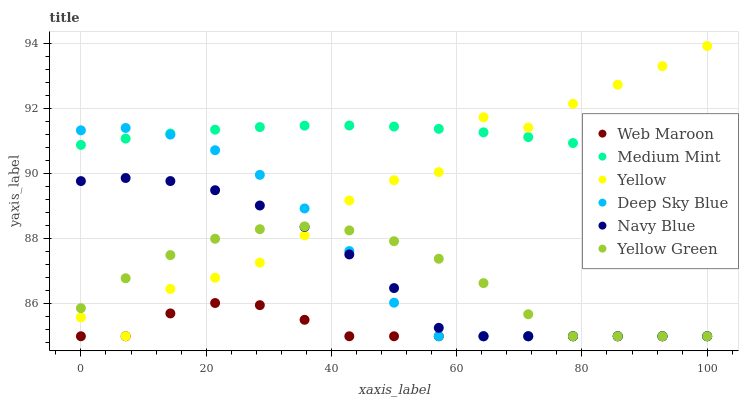Does Web Maroon have the minimum area under the curve?
Answer yes or no. Yes. Does Medium Mint have the maximum area under the curve?
Answer yes or no. Yes. Does Yellow Green have the minimum area under the curve?
Answer yes or no. No. Does Yellow Green have the maximum area under the curve?
Answer yes or no. No. Is Medium Mint the smoothest?
Answer yes or no. Yes. Is Yellow the roughest?
Answer yes or no. Yes. Is Yellow Green the smoothest?
Answer yes or no. No. Is Yellow Green the roughest?
Answer yes or no. No. Does Yellow Green have the lowest value?
Answer yes or no. Yes. Does Yellow have the lowest value?
Answer yes or no. No. Does Yellow have the highest value?
Answer yes or no. Yes. Does Yellow Green have the highest value?
Answer yes or no. No. Is Yellow Green less than Medium Mint?
Answer yes or no. Yes. Is Medium Mint greater than Yellow Green?
Answer yes or no. Yes. Does Navy Blue intersect Yellow Green?
Answer yes or no. Yes. Is Navy Blue less than Yellow Green?
Answer yes or no. No. Is Navy Blue greater than Yellow Green?
Answer yes or no. No. Does Yellow Green intersect Medium Mint?
Answer yes or no. No. 